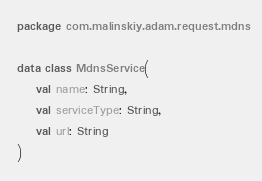<code> <loc_0><loc_0><loc_500><loc_500><_Kotlin_>package com.malinskiy.adam.request.mdns

data class MdnsService(
    val name: String,
    val serviceType: String,
    val url: String
)
</code> 